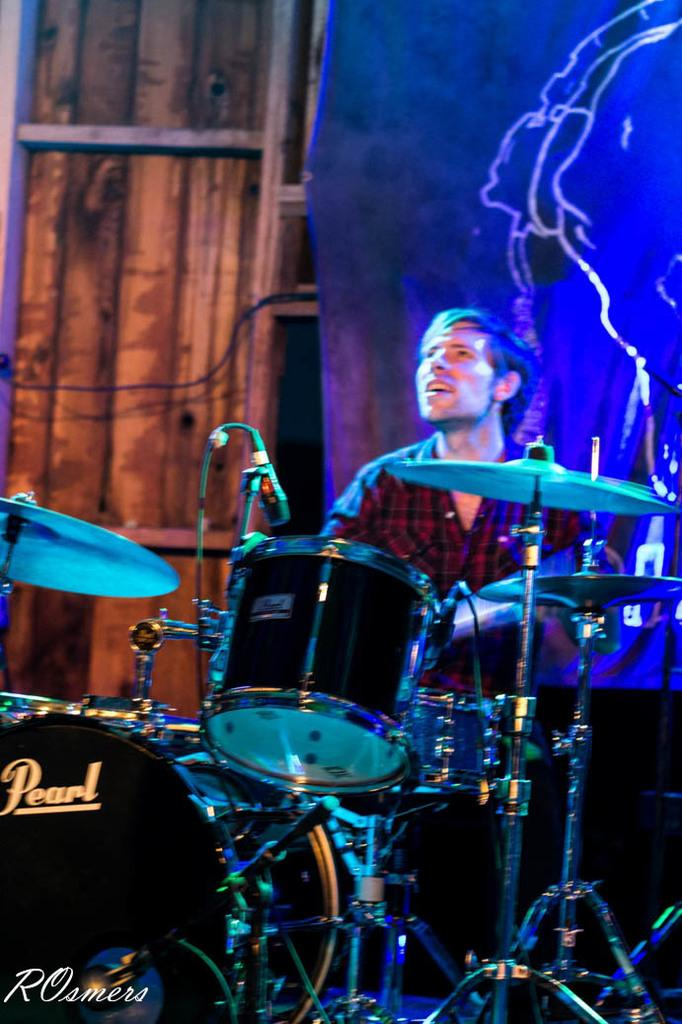Who is the main subject in the image? There is a man in the image. What is the man wearing? The man is wearing a red shirt. What is the man doing in the image? The man is playing drums. What can be seen in the front of the image? There is a band setup in the front of the image. What is visible in the background of the image? There is a banner and a wooden wall in the background of the image. What shape is the door in the image? There is no door present in the image. What hour is it in the image? The image does not provide any information about the time of day, so it is impossible to determine the hour. 